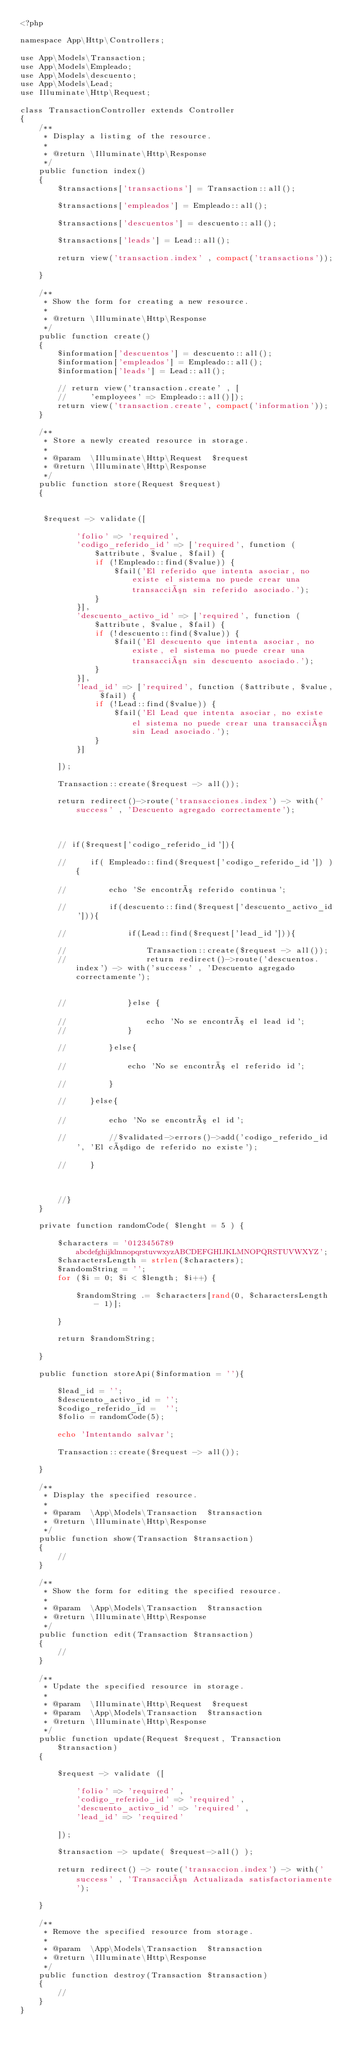Convert code to text. <code><loc_0><loc_0><loc_500><loc_500><_PHP_><?php

namespace App\Http\Controllers;

use App\Models\Transaction;
use App\Models\Empleado;
use App\Models\descuento;
use App\Models\Lead;
use Illuminate\Http\Request;

class TransactionController extends Controller
{
    /**
     * Display a listing of the resource.
     *
     * @return \Illuminate\Http\Response
     */
    public function index()
    {
        $transactions['transactions'] = Transaction::all();

        $transactions['empleados'] = Empleado::all();

        $transactions['descuentos'] = descuento::all();

        $transactions['leads'] = Lead::all();

        return view('transaction.index' , compact('transactions'));

    }

    /**
     * Show the form for creating a new resource.
     *
     * @return \Illuminate\Http\Response
     */
    public function create()
    {
        $information['descuentos'] = descuento::all();
        $information['empleados'] = Empleado::all();
        $information['leads'] = Lead::all();

        // return view('transaction.create' , [
        //     'employees' => Empleado::all()]);
        return view('transaction.create', compact('information'));
    }

    /**
     * Store a newly created resource in storage.
     *
     * @param  \Illuminate\Http\Request  $request
     * @return \Illuminate\Http\Response
     */
    public function store(Request $request)
    {
        

     $request -> validate([
            
            'folio' => 'required',
            'codigo_referido_id' => ['required', function ($attribute, $value, $fail) {
                if (!Empleado::find($value)) {
                    $fail('El referido que intenta asociar, no existe el sistema no puede crear una transacción sin referido asociado.');
                }
            }],
            'descuento_activo_id' => ['required', function ($attribute, $value, $fail) {
                if (!descuento::find($value)) {
                    $fail('El descuento que intenta asociar, no existe, el sistema no puede crear una transacción sin descuento asociado.');
                }
            }],
            'lead_id' => ['required', function ($attribute, $value, $fail) {
                if (!Lead::find($value)) {
                    $fail('El Lead que intenta asociar, no existe el sistema no puede crear una transacción sin Lead asociado.');
                }
            }]

        ]);

        Transaction::create($request -> all());

        return redirect()->route('transacciones.index') -> with('success' , 'Descuento agregado correctamente');



        // if($request['codigo_referido_id']){
            
        //     if( Empleado::find($request['codigo_referido_id']) ){

        //         echo 'Se encontró referido continua';

        //         if(descuento::find($request['descuento_activo_id'])){

        //             if(Lead::find($request['lead_id'])){

        //                 Transaction::create($request -> all());
        //                 return redirect()->route('descuentos.index') -> with('success' , 'Descuento agregado correctamente');


        //             }else {

        //                 echo 'No se encontró el lead id';
        //             }

        //         }else{

        //             echo 'No se encontró el referido id';

        //         }

        //     }else{

        //         echo 'No se encontró el id';

        //         //$validated->errors()->add('codigo_referido_id', 'El código de referido no existe');

        //     }
        
        

        //}
    }

    private function randomCode( $lenght = 5 ) {

        $characters = '0123456789abcdefghijklmnopqrstuvwxyzABCDEFGHIJKLMNOPQRSTUVWXYZ';
        $charactersLength = strlen($characters);
        $randomString = '';
        for ($i = 0; $i < $length; $i++) {

            $randomString .= $characters[rand(0, $charactersLength - 1)];

        }

        return $randomString;

    }

    public function storeApi($information = ''){

        $lead_id = '';
        $descuento_activo_id = '';
        $codigo_referido_id =  '';
        $folio = randomCode(5);

        echo 'Intentando salvar';

        Transaction::create($request -> all());

    }

    /**
     * Display the specified resource.
     *
     * @param  \App\Models\Transaction  $transaction
     * @return \Illuminate\Http\Response
     */
    public function show(Transaction $transaction)
    {
        //
    }

    /**
     * Show the form for editing the specified resource.
     *
     * @param  \App\Models\Transaction  $transaction
     * @return \Illuminate\Http\Response
     */
    public function edit(Transaction $transaction)
    {
        //
    }

    /**
     * Update the specified resource in storage.
     *
     * @param  \Illuminate\Http\Request  $request
     * @param  \App\Models\Transaction  $transaction
     * @return \Illuminate\Http\Response
     */
    public function update(Request $request, Transaction $transaction)
    {

        $request -> validate ([

            'folio' => 'required' ,
            'codigo_referido_id' => 'required' ,
            'descuento_activo_id' => 'required' ,
            'lead_id' => 'required'

        ]);

        $transaction -> update( $request->all() );

        return redirect() -> route('transaccion.index') -> with('success' , 'Transacción Actualizada satisfactoriamente');

    }

    /**
     * Remove the specified resource from storage.
     *
     * @param  \App\Models\Transaction  $transaction
     * @return \Illuminate\Http\Response
     */
    public function destroy(Transaction $transaction)
    {
        //
    }
}
</code> 